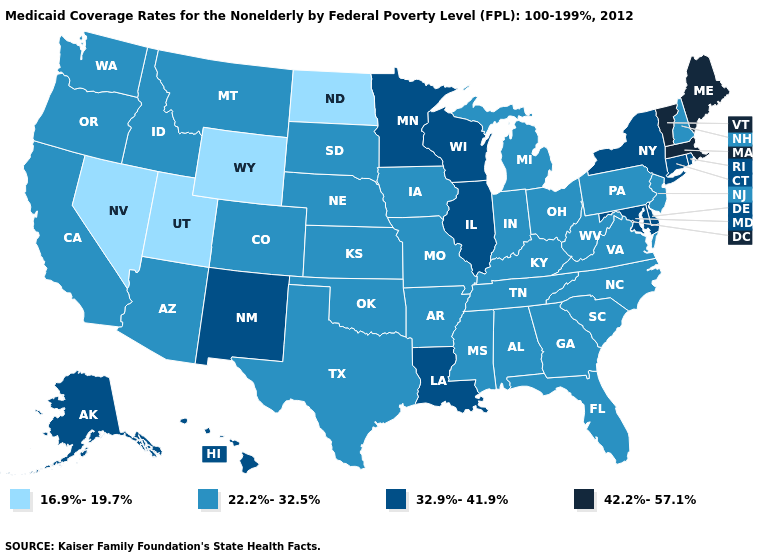What is the value of Nevada?
Give a very brief answer. 16.9%-19.7%. What is the value of Alaska?
Write a very short answer. 32.9%-41.9%. What is the value of Washington?
Quick response, please. 22.2%-32.5%. What is the lowest value in states that border North Carolina?
Be succinct. 22.2%-32.5%. Name the states that have a value in the range 42.2%-57.1%?
Write a very short answer. Maine, Massachusetts, Vermont. Which states hav the highest value in the MidWest?
Short answer required. Illinois, Minnesota, Wisconsin. Among the states that border Indiana , which have the lowest value?
Concise answer only. Kentucky, Michigan, Ohio. What is the highest value in states that border North Carolina?
Give a very brief answer. 22.2%-32.5%. Is the legend a continuous bar?
Write a very short answer. No. What is the value of Ohio?
Concise answer only. 22.2%-32.5%. Among the states that border North Dakota , which have the lowest value?
Concise answer only. Montana, South Dakota. What is the lowest value in states that border Arkansas?
Give a very brief answer. 22.2%-32.5%. Name the states that have a value in the range 32.9%-41.9%?
Quick response, please. Alaska, Connecticut, Delaware, Hawaii, Illinois, Louisiana, Maryland, Minnesota, New Mexico, New York, Rhode Island, Wisconsin. What is the value of Washington?
Give a very brief answer. 22.2%-32.5%. What is the value of Louisiana?
Give a very brief answer. 32.9%-41.9%. 